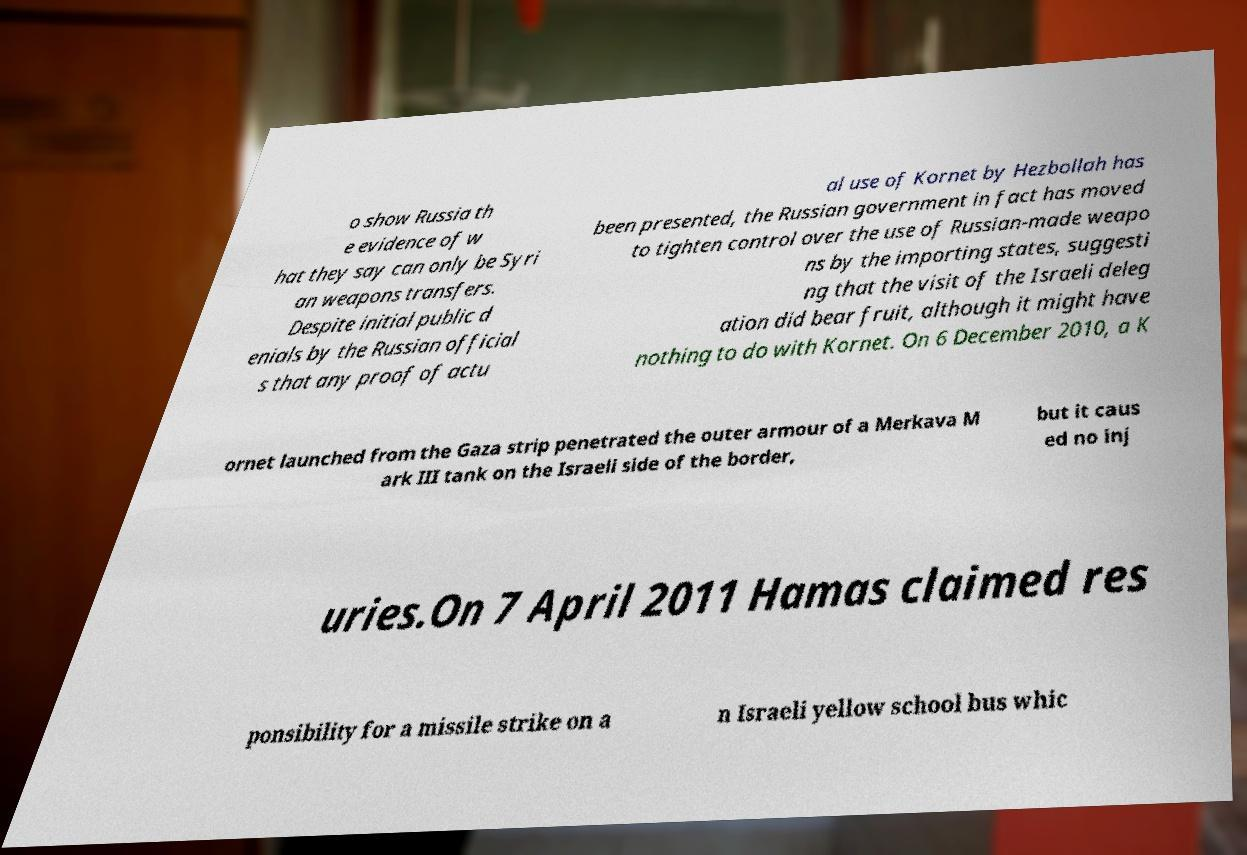Could you extract and type out the text from this image? o show Russia th e evidence of w hat they say can only be Syri an weapons transfers. Despite initial public d enials by the Russian official s that any proof of actu al use of Kornet by Hezbollah has been presented, the Russian government in fact has moved to tighten control over the use of Russian-made weapo ns by the importing states, suggesti ng that the visit of the Israeli deleg ation did bear fruit, although it might have nothing to do with Kornet. On 6 December 2010, a K ornet launched from the Gaza strip penetrated the outer armour of a Merkava M ark III tank on the Israeli side of the border, but it caus ed no inj uries.On 7 April 2011 Hamas claimed res ponsibility for a missile strike on a n Israeli yellow school bus whic 